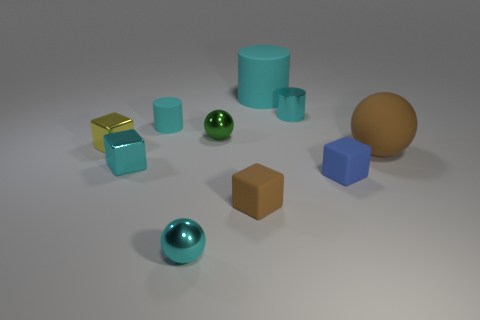Subtract all gray cylinders. Subtract all red cubes. How many cylinders are left? 3 Subtract all cylinders. How many objects are left? 7 Subtract all yellow shiny things. Subtract all tiny cyan objects. How many objects are left? 5 Add 6 cyan shiny objects. How many cyan shiny objects are left? 9 Add 8 matte cylinders. How many matte cylinders exist? 10 Subtract 1 blue cubes. How many objects are left? 9 